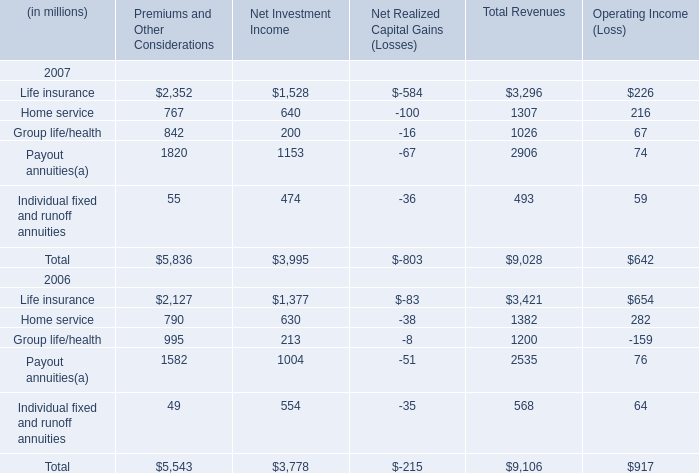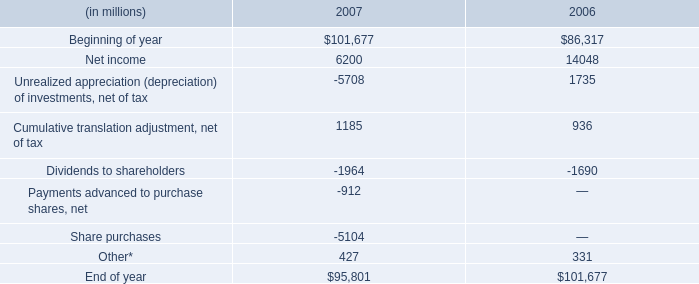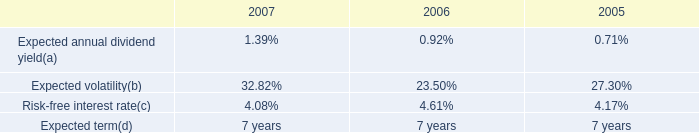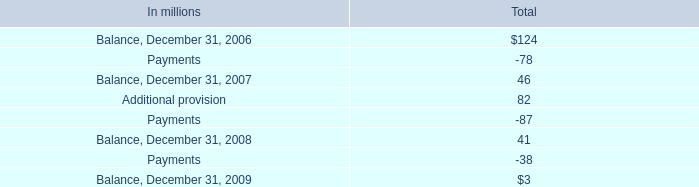in 2006 what was the ratio of the class a shares and promissory notes international paper contributed in the acquisition of borrower entities interest 
Computations: (200 / 400)
Answer: 0.5. 